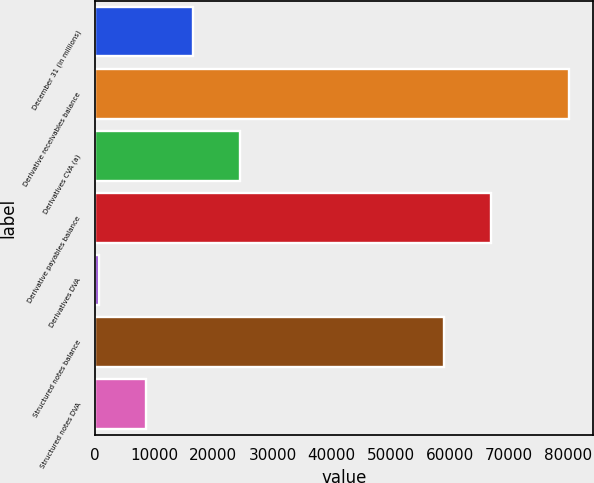Convert chart to OTSL. <chart><loc_0><loc_0><loc_500><loc_500><bar_chart><fcel>December 31 (in millions)<fcel>Derivative receivables balance<fcel>Derivatives CVA (a)<fcel>Derivative payables balance<fcel>Derivatives DVA<fcel>Structured notes balance<fcel>Structured notes DVA<nl><fcel>16545.2<fcel>80210<fcel>24503.3<fcel>67022.1<fcel>629<fcel>59064<fcel>8587.1<nl></chart> 